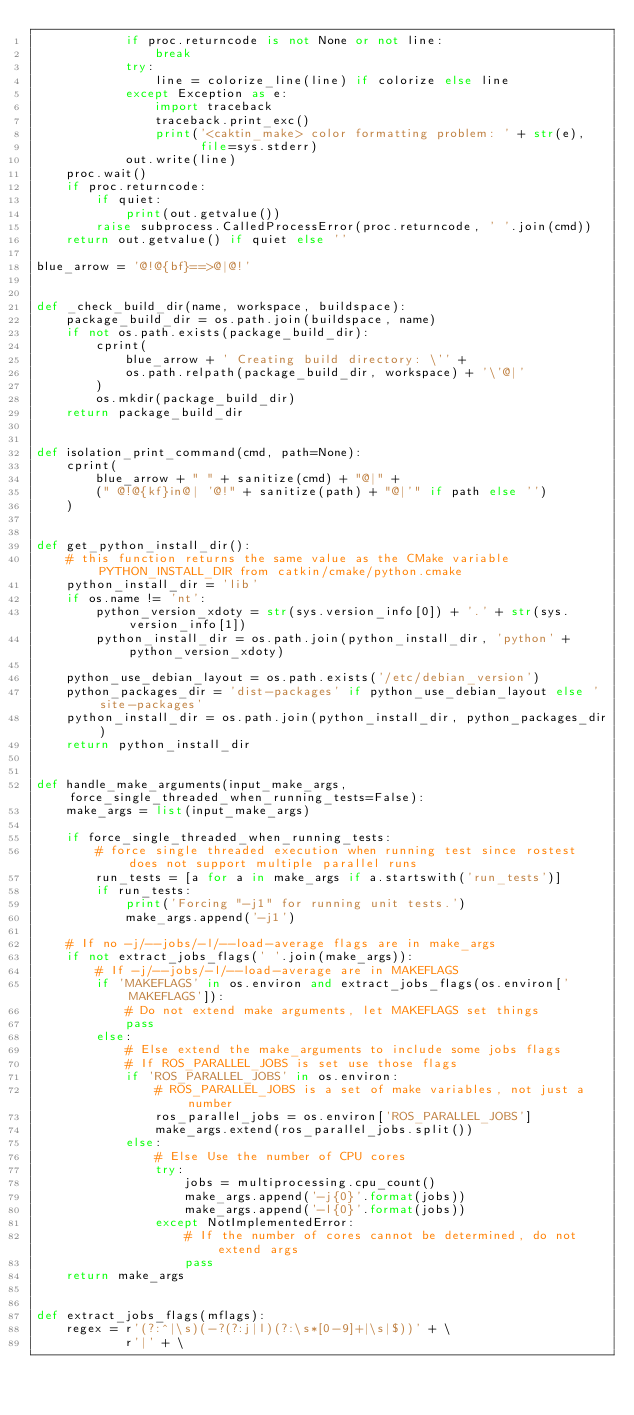<code> <loc_0><loc_0><loc_500><loc_500><_Python_>            if proc.returncode is not None or not line:
                break
            try:
                line = colorize_line(line) if colorize else line
            except Exception as e:
                import traceback
                traceback.print_exc()
                print('<caktin_make> color formatting problem: ' + str(e),
                      file=sys.stderr)
            out.write(line)
    proc.wait()
    if proc.returncode:
        if quiet:
            print(out.getvalue())
        raise subprocess.CalledProcessError(proc.returncode, ' '.join(cmd))
    return out.getvalue() if quiet else ''

blue_arrow = '@!@{bf}==>@|@!'


def _check_build_dir(name, workspace, buildspace):
    package_build_dir = os.path.join(buildspace, name)
    if not os.path.exists(package_build_dir):
        cprint(
            blue_arrow + ' Creating build directory: \'' +
            os.path.relpath(package_build_dir, workspace) + '\'@|'
        )
        os.mkdir(package_build_dir)
    return package_build_dir


def isolation_print_command(cmd, path=None):
    cprint(
        blue_arrow + " " + sanitize(cmd) + "@|" +
        (" @!@{kf}in@| '@!" + sanitize(path) + "@|'" if path else '')
    )


def get_python_install_dir():
    # this function returns the same value as the CMake variable PYTHON_INSTALL_DIR from catkin/cmake/python.cmake
    python_install_dir = 'lib'
    if os.name != 'nt':
        python_version_xdoty = str(sys.version_info[0]) + '.' + str(sys.version_info[1])
        python_install_dir = os.path.join(python_install_dir, 'python' + python_version_xdoty)

    python_use_debian_layout = os.path.exists('/etc/debian_version')
    python_packages_dir = 'dist-packages' if python_use_debian_layout else 'site-packages'
    python_install_dir = os.path.join(python_install_dir, python_packages_dir)
    return python_install_dir


def handle_make_arguments(input_make_args, force_single_threaded_when_running_tests=False):
    make_args = list(input_make_args)

    if force_single_threaded_when_running_tests:
        # force single threaded execution when running test since rostest does not support multiple parallel runs
        run_tests = [a for a in make_args if a.startswith('run_tests')]
        if run_tests:
            print('Forcing "-j1" for running unit tests.')
            make_args.append('-j1')

    # If no -j/--jobs/-l/--load-average flags are in make_args
    if not extract_jobs_flags(' '.join(make_args)):
        # If -j/--jobs/-l/--load-average are in MAKEFLAGS
        if 'MAKEFLAGS' in os.environ and extract_jobs_flags(os.environ['MAKEFLAGS']):
            # Do not extend make arguments, let MAKEFLAGS set things
            pass
        else:
            # Else extend the make_arguments to include some jobs flags
            # If ROS_PARALLEL_JOBS is set use those flags
            if 'ROS_PARALLEL_JOBS' in os.environ:
                # ROS_PARALLEL_JOBS is a set of make variables, not just a number
                ros_parallel_jobs = os.environ['ROS_PARALLEL_JOBS']
                make_args.extend(ros_parallel_jobs.split())
            else:
                # Else Use the number of CPU cores
                try:
                    jobs = multiprocessing.cpu_count()
                    make_args.append('-j{0}'.format(jobs))
                    make_args.append('-l{0}'.format(jobs))
                except NotImplementedError:
                    # If the number of cores cannot be determined, do not extend args
                    pass
    return make_args


def extract_jobs_flags(mflags):
    regex = r'(?:^|\s)(-?(?:j|l)(?:\s*[0-9]+|\s|$))' + \
            r'|' + \</code> 